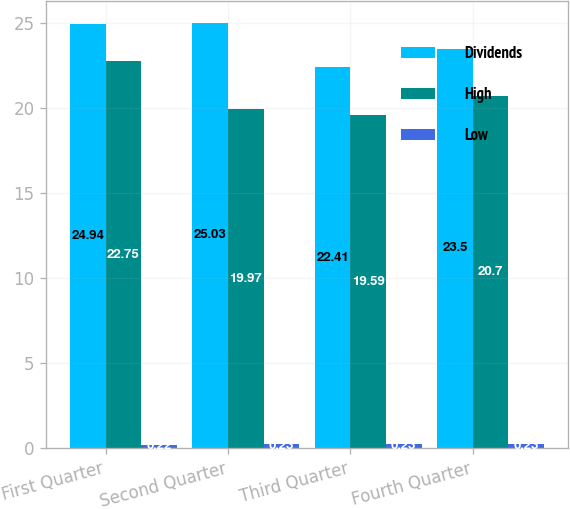Convert chart to OTSL. <chart><loc_0><loc_0><loc_500><loc_500><stacked_bar_chart><ecel><fcel>First Quarter<fcel>Second Quarter<fcel>Third Quarter<fcel>Fourth Quarter<nl><fcel>Dividends<fcel>24.94<fcel>25.03<fcel>22.41<fcel>23.5<nl><fcel>High<fcel>22.75<fcel>19.97<fcel>19.59<fcel>20.7<nl><fcel>Low<fcel>0.22<fcel>0.23<fcel>0.23<fcel>0.23<nl></chart> 